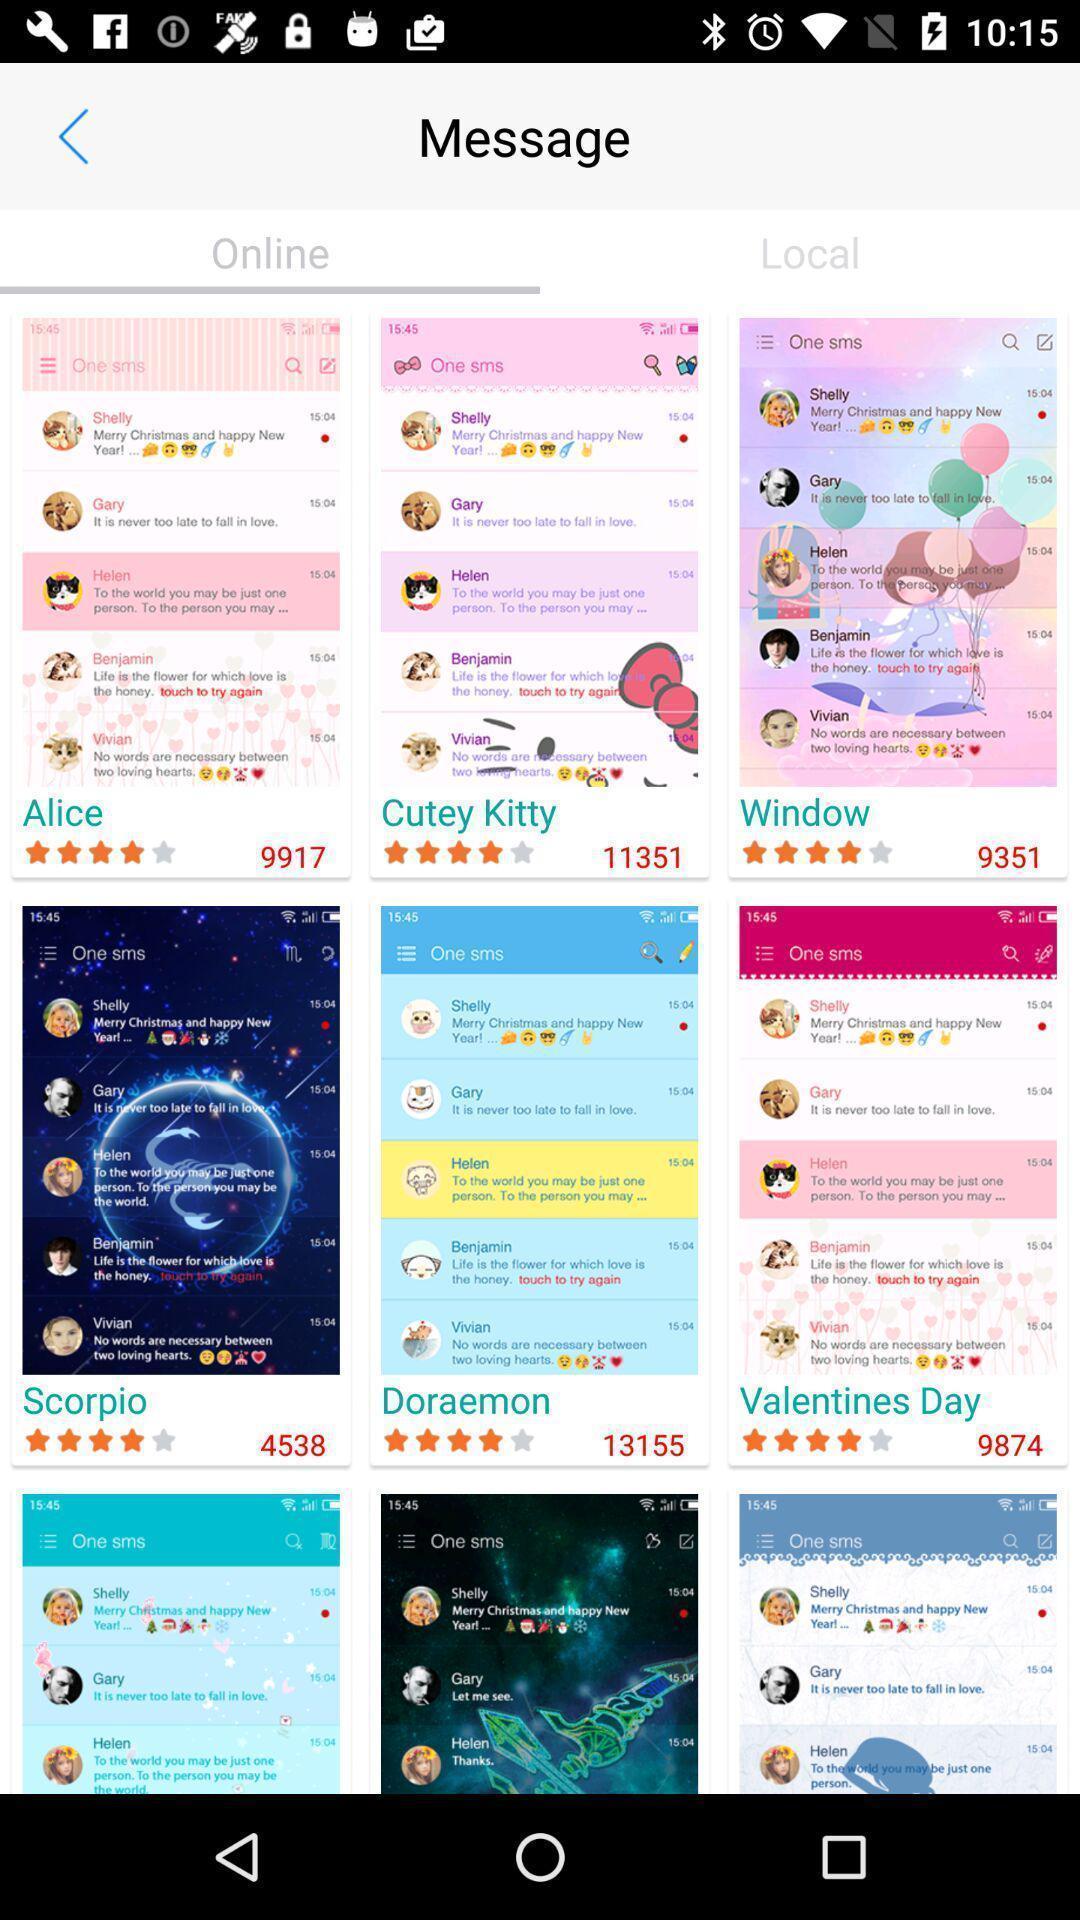Provide a detailed account of this screenshot. Screen shows a page of online messages. 